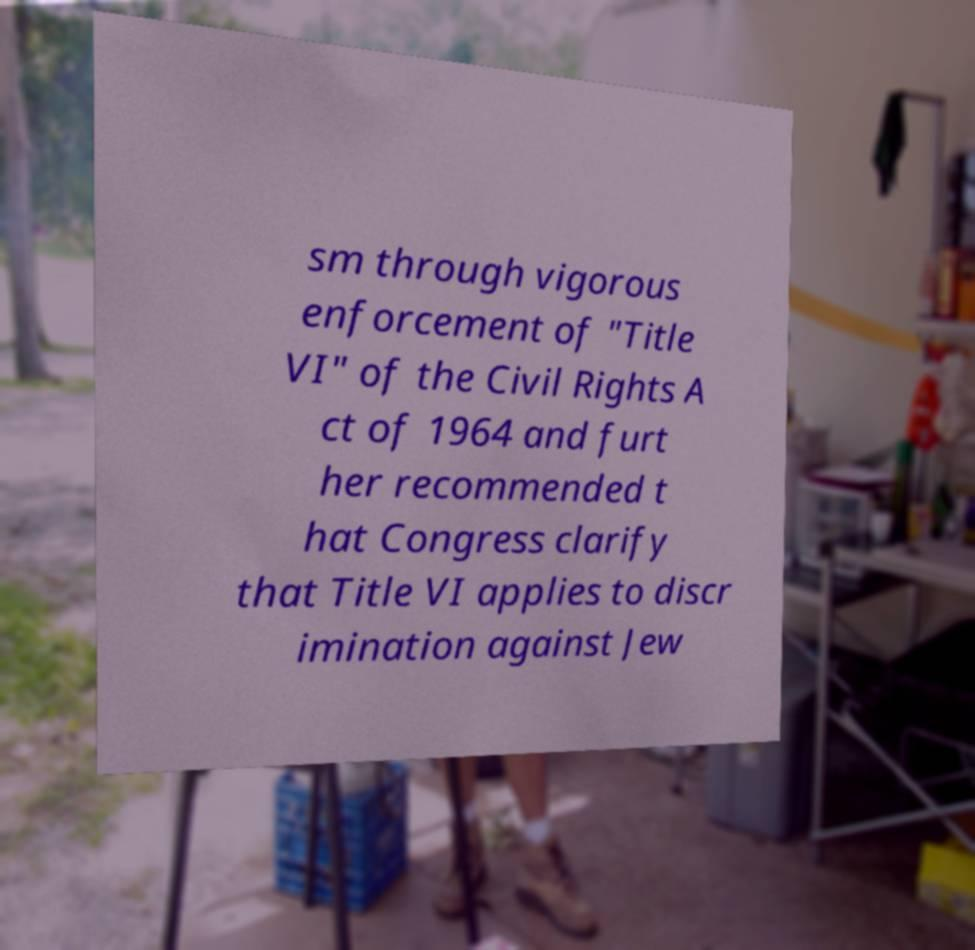For documentation purposes, I need the text within this image transcribed. Could you provide that? sm through vigorous enforcement of "Title VI" of the Civil Rights A ct of 1964 and furt her recommended t hat Congress clarify that Title VI applies to discr imination against Jew 